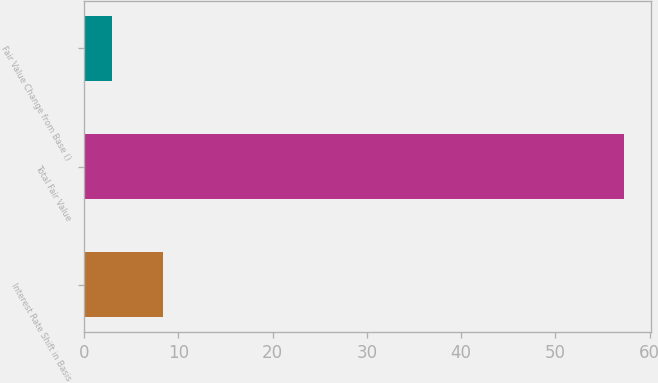Convert chart to OTSL. <chart><loc_0><loc_0><loc_500><loc_500><bar_chart><fcel>Interest Rate Shift in Basis<fcel>Total Fair Value<fcel>Fair Value Change from Base ()<nl><fcel>8.38<fcel>57.3<fcel>2.95<nl></chart> 